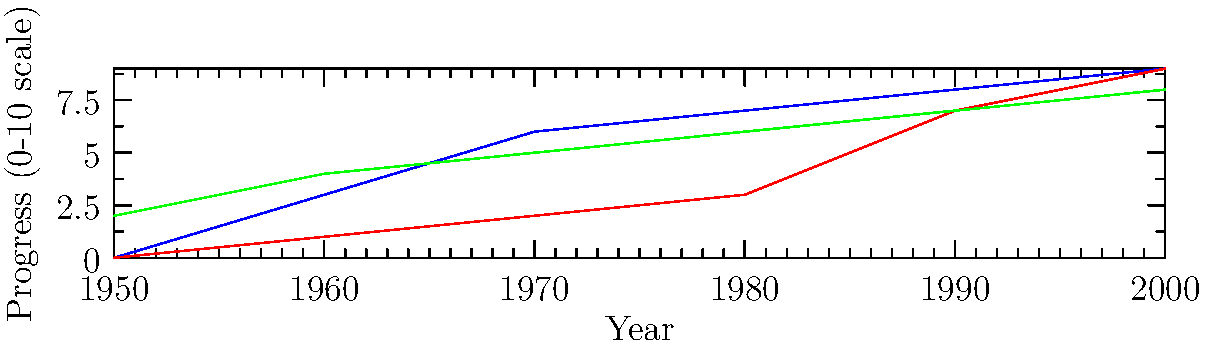Based on the graph depicting the progress of civil rights movements in the USA, South Africa, and India from 1950 to 2000, which country experienced the most significant acceleration in civil rights progress between 1980 and 1990? To answer this question, we need to analyze the slopes of the lines for each country between 1980 and 1990:

1. USA:
   - 1980 value: 7
   - 1990 value: 8
   - Change: 1 point

2. South Africa:
   - 1980 value: 3
   - 1990 value: 7
   - Change: 4 points

3. India:
   - 1980 value: 6
   - 1990 value: 7
   - Change: 1 point

The steepest slope, indicating the most significant acceleration in civil rights progress, is observed for South Africa, with a 4-point increase during this decade. This sharp rise likely corresponds to the intensification of anti-apartheid movements and international pressure during the 1980s, culminating in the release of Nelson Mandela in 1990 and the subsequent end of apartheid.

In contrast, both the USA and India show more gradual progress during this period, with only a 1-point increase each. This suggests that while these countries continued to make advancements in civil rights, the pace of change was not as dramatic as in South Africa during this specific timeframe.
Answer: South Africa 